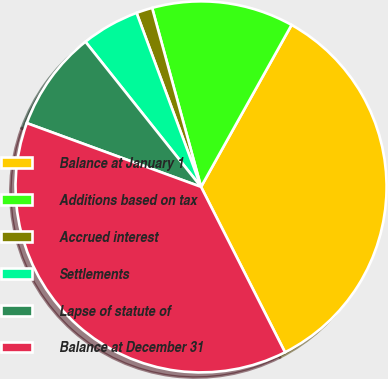Convert chart to OTSL. <chart><loc_0><loc_0><loc_500><loc_500><pie_chart><fcel>Balance at January 1<fcel>Additions based on tax<fcel>Accrued interest<fcel>Settlements<fcel>Lapse of statute of<fcel>Balance at December 31<nl><fcel>34.41%<fcel>12.36%<fcel>1.4%<fcel>5.06%<fcel>8.71%<fcel>38.06%<nl></chart> 